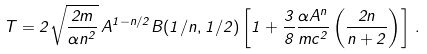Convert formula to latex. <formula><loc_0><loc_0><loc_500><loc_500>T = 2 \sqrt { \frac { 2 m } { \alpha n ^ { 2 } } } \, A ^ { 1 - n / 2 } B ( 1 / n , 1 / 2 ) \left [ 1 + \frac { 3 } { 8 } \frac { \alpha A ^ { n } } { m c ^ { 2 } } \left ( \frac { 2 n } { n + 2 } \right ) \right ] \, .</formula> 